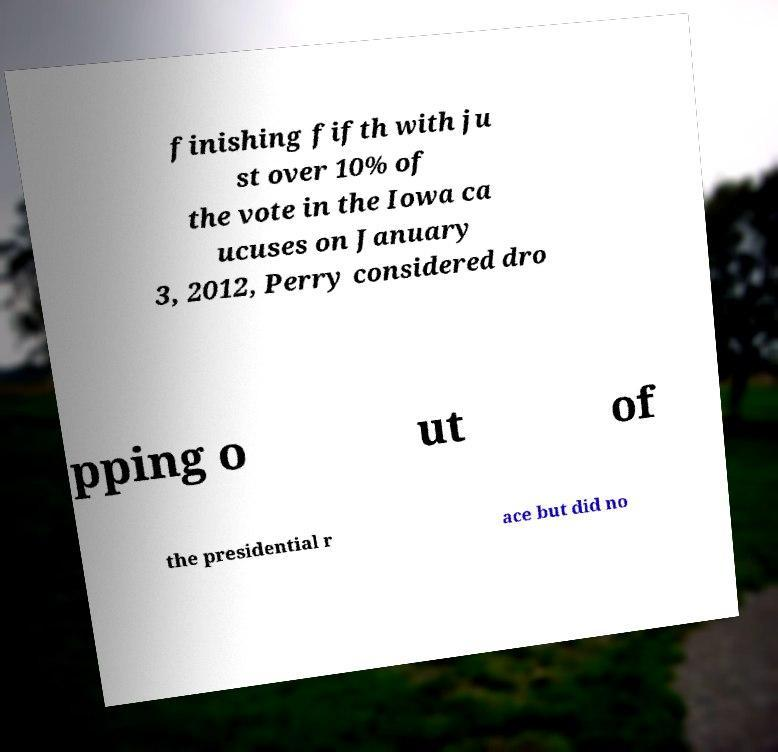Can you read and provide the text displayed in the image?This photo seems to have some interesting text. Can you extract and type it out for me? finishing fifth with ju st over 10% of the vote in the Iowa ca ucuses on January 3, 2012, Perry considered dro pping o ut of the presidential r ace but did no 